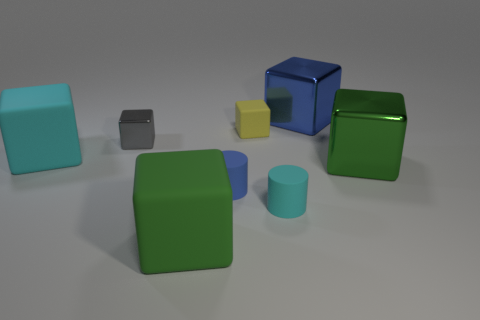What is the color of the other large metal thing that is the same shape as the blue metal thing? green 